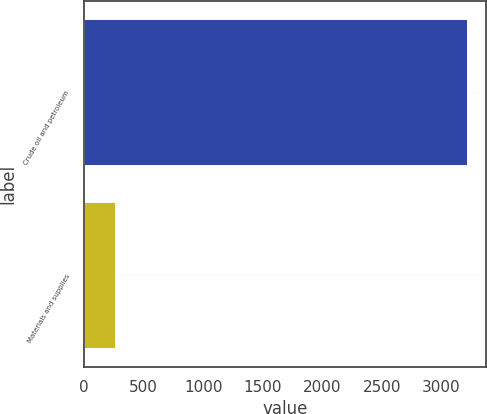Convert chart to OTSL. <chart><loc_0><loc_0><loc_500><loc_500><bar_chart><fcel>Crude oil and petroleum<fcel>Materials and supplies<nl><fcel>3214<fcel>263<nl></chart> 